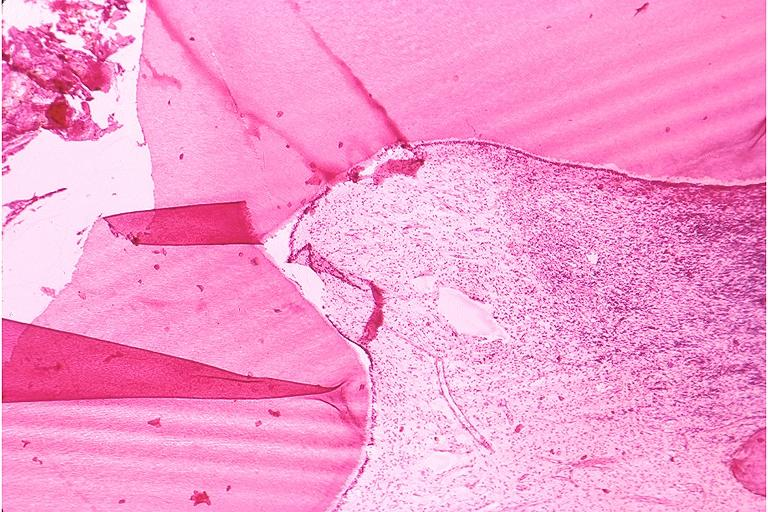does this image show chronic pulpitis?
Answer the question using a single word or phrase. Yes 